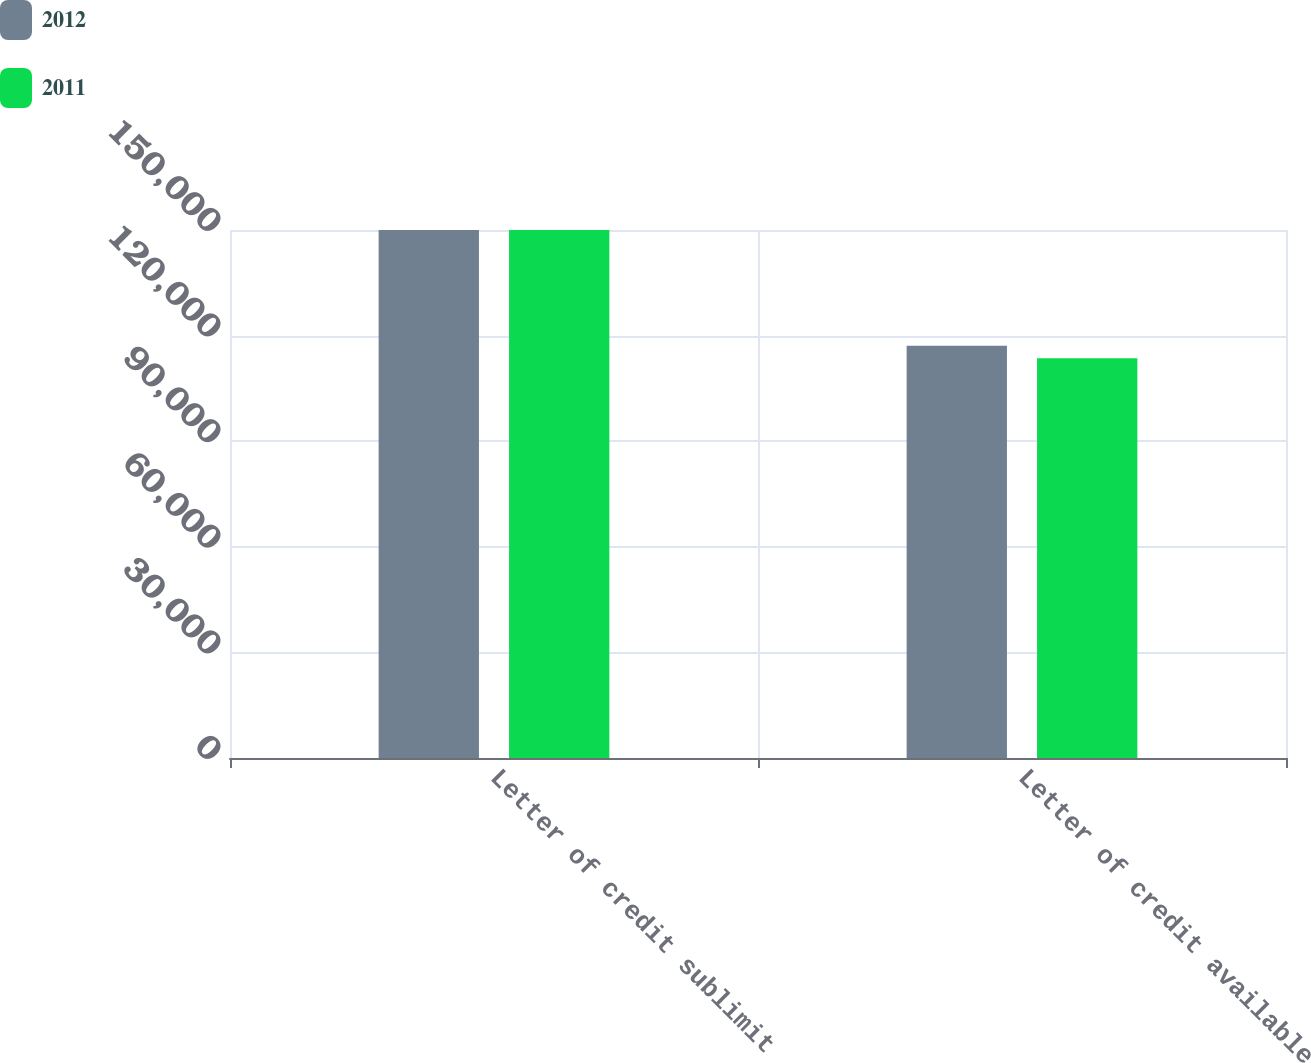Convert chart to OTSL. <chart><loc_0><loc_0><loc_500><loc_500><stacked_bar_chart><ecel><fcel>Letter of credit sublimit<fcel>Letter of credit available<nl><fcel>2012<fcel>150000<fcel>117137<nl><fcel>2011<fcel>150000<fcel>113548<nl></chart> 